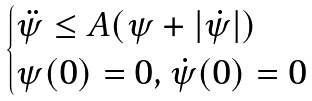<formula> <loc_0><loc_0><loc_500><loc_500>\begin{cases} \ddot { \psi } \leq A ( \psi + | \dot { \psi } | ) \\ \psi ( 0 ) = 0 , \dot { \psi } ( 0 ) = 0 \end{cases}</formula> 